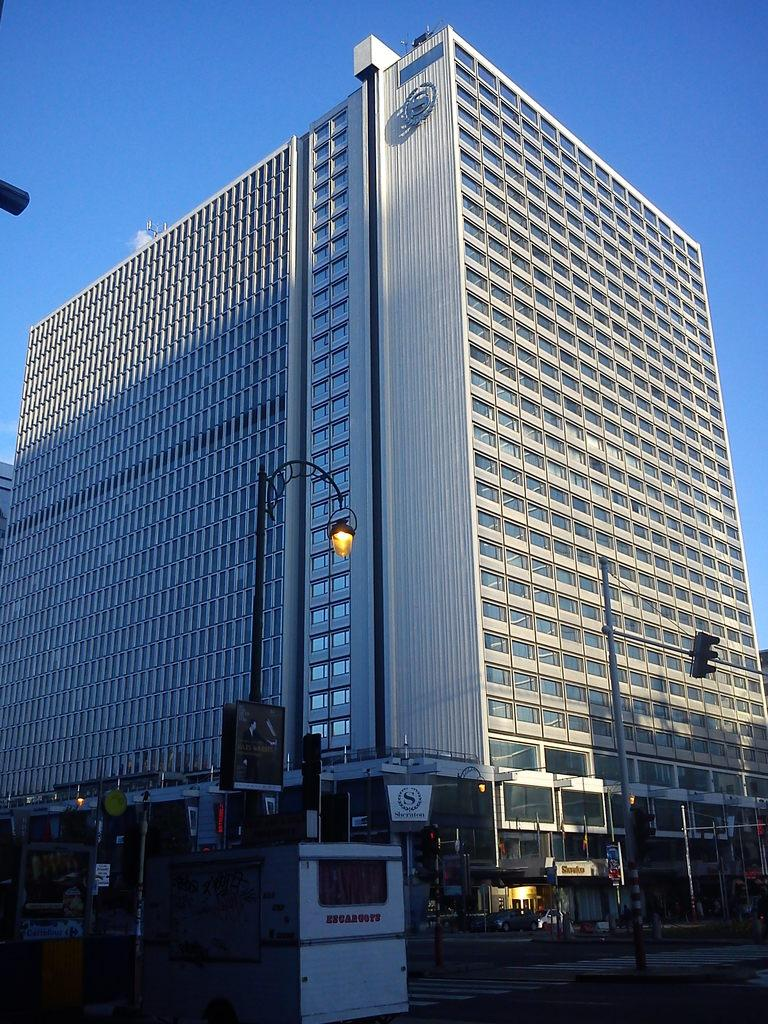What is located on a pole in the image? There is a light, a box, and a traffic signal on a pole in the image. What type of electrical device is visible in the image? An electrical device is visible in the image, but its specific type is not mentioned. What can be seen in the background of the image? There is a building and a blue sky in the background of the image. What type of sink is visible in the image? There is no sink present in the image. What property is associated with the building in the background of the image? The provided facts do not mention any specific property associated with the building in the background. 